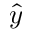<formula> <loc_0><loc_0><loc_500><loc_500>\hat { y }</formula> 